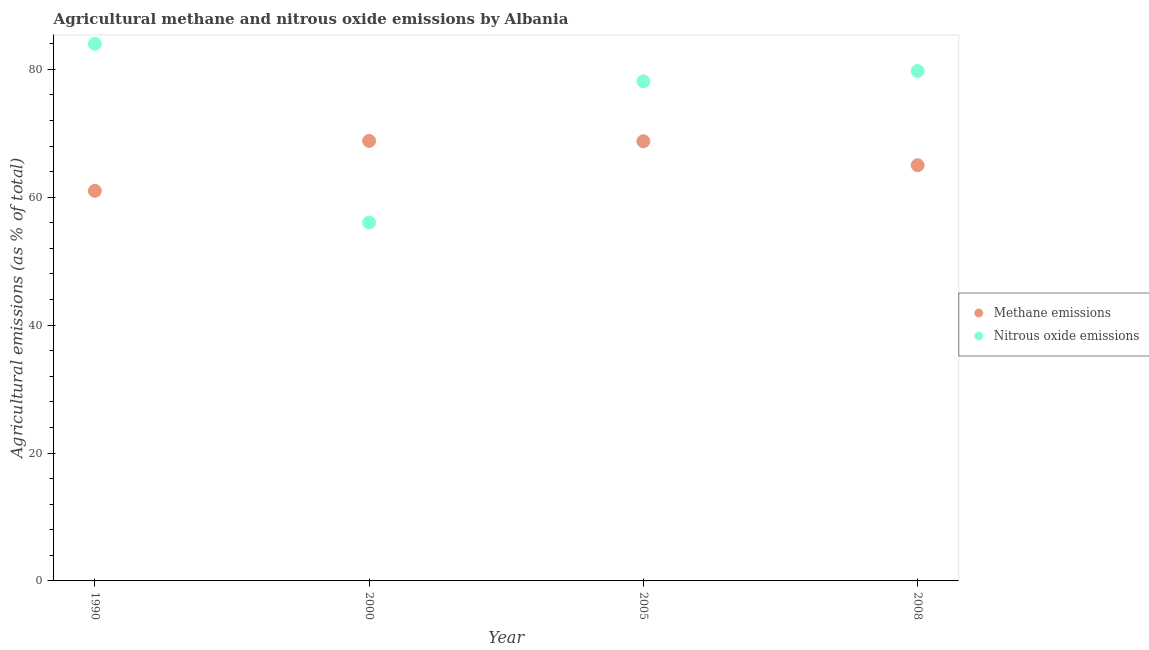Is the number of dotlines equal to the number of legend labels?
Give a very brief answer. Yes. What is the amount of methane emissions in 2008?
Make the answer very short. 65. Across all years, what is the maximum amount of nitrous oxide emissions?
Offer a terse response. 83.98. Across all years, what is the minimum amount of methane emissions?
Keep it short and to the point. 60.99. What is the total amount of methane emissions in the graph?
Keep it short and to the point. 263.54. What is the difference between the amount of nitrous oxide emissions in 1990 and that in 2008?
Your answer should be compact. 4.26. What is the difference between the amount of methane emissions in 1990 and the amount of nitrous oxide emissions in 2008?
Provide a short and direct response. -18.73. What is the average amount of nitrous oxide emissions per year?
Give a very brief answer. 74.46. In the year 2000, what is the difference between the amount of methane emissions and amount of nitrous oxide emissions?
Ensure brevity in your answer.  12.76. In how many years, is the amount of methane emissions greater than 12 %?
Give a very brief answer. 4. What is the ratio of the amount of methane emissions in 2000 to that in 2008?
Provide a short and direct response. 1.06. Is the amount of nitrous oxide emissions in 2000 less than that in 2008?
Ensure brevity in your answer.  Yes. Is the difference between the amount of nitrous oxide emissions in 2000 and 2008 greater than the difference between the amount of methane emissions in 2000 and 2008?
Provide a short and direct response. No. What is the difference between the highest and the second highest amount of methane emissions?
Your response must be concise. 0.06. What is the difference between the highest and the lowest amount of methane emissions?
Provide a short and direct response. 7.81. Is the amount of methane emissions strictly greater than the amount of nitrous oxide emissions over the years?
Your answer should be very brief. No. How many years are there in the graph?
Offer a terse response. 4. What is the difference between two consecutive major ticks on the Y-axis?
Keep it short and to the point. 20. Are the values on the major ticks of Y-axis written in scientific E-notation?
Offer a very short reply. No. Does the graph contain grids?
Provide a succinct answer. No. How many legend labels are there?
Your answer should be very brief. 2. What is the title of the graph?
Offer a terse response. Agricultural methane and nitrous oxide emissions by Albania. What is the label or title of the Y-axis?
Ensure brevity in your answer.  Agricultural emissions (as % of total). What is the Agricultural emissions (as % of total) in Methane emissions in 1990?
Provide a short and direct response. 60.99. What is the Agricultural emissions (as % of total) in Nitrous oxide emissions in 1990?
Give a very brief answer. 83.98. What is the Agricultural emissions (as % of total) of Methane emissions in 2000?
Keep it short and to the point. 68.8. What is the Agricultural emissions (as % of total) in Nitrous oxide emissions in 2000?
Give a very brief answer. 56.04. What is the Agricultural emissions (as % of total) of Methane emissions in 2005?
Give a very brief answer. 68.75. What is the Agricultural emissions (as % of total) in Nitrous oxide emissions in 2005?
Your response must be concise. 78.11. What is the Agricultural emissions (as % of total) in Methane emissions in 2008?
Your answer should be very brief. 65. What is the Agricultural emissions (as % of total) of Nitrous oxide emissions in 2008?
Offer a very short reply. 79.72. Across all years, what is the maximum Agricultural emissions (as % of total) in Methane emissions?
Ensure brevity in your answer.  68.8. Across all years, what is the maximum Agricultural emissions (as % of total) of Nitrous oxide emissions?
Provide a short and direct response. 83.98. Across all years, what is the minimum Agricultural emissions (as % of total) in Methane emissions?
Offer a very short reply. 60.99. Across all years, what is the minimum Agricultural emissions (as % of total) in Nitrous oxide emissions?
Offer a very short reply. 56.04. What is the total Agricultural emissions (as % of total) in Methane emissions in the graph?
Ensure brevity in your answer.  263.54. What is the total Agricultural emissions (as % of total) in Nitrous oxide emissions in the graph?
Offer a very short reply. 297.85. What is the difference between the Agricultural emissions (as % of total) of Methane emissions in 1990 and that in 2000?
Make the answer very short. -7.81. What is the difference between the Agricultural emissions (as % of total) in Nitrous oxide emissions in 1990 and that in 2000?
Your response must be concise. 27.94. What is the difference between the Agricultural emissions (as % of total) of Methane emissions in 1990 and that in 2005?
Provide a succinct answer. -7.75. What is the difference between the Agricultural emissions (as % of total) in Nitrous oxide emissions in 1990 and that in 2005?
Ensure brevity in your answer.  5.87. What is the difference between the Agricultural emissions (as % of total) of Methane emissions in 1990 and that in 2008?
Offer a very short reply. -4.01. What is the difference between the Agricultural emissions (as % of total) in Nitrous oxide emissions in 1990 and that in 2008?
Make the answer very short. 4.26. What is the difference between the Agricultural emissions (as % of total) of Methane emissions in 2000 and that in 2005?
Offer a terse response. 0.06. What is the difference between the Agricultural emissions (as % of total) of Nitrous oxide emissions in 2000 and that in 2005?
Your answer should be compact. -22.07. What is the difference between the Agricultural emissions (as % of total) in Methane emissions in 2000 and that in 2008?
Make the answer very short. 3.8. What is the difference between the Agricultural emissions (as % of total) of Nitrous oxide emissions in 2000 and that in 2008?
Your answer should be very brief. -23.68. What is the difference between the Agricultural emissions (as % of total) in Methane emissions in 2005 and that in 2008?
Provide a succinct answer. 3.75. What is the difference between the Agricultural emissions (as % of total) of Nitrous oxide emissions in 2005 and that in 2008?
Provide a succinct answer. -1.61. What is the difference between the Agricultural emissions (as % of total) in Methane emissions in 1990 and the Agricultural emissions (as % of total) in Nitrous oxide emissions in 2000?
Your response must be concise. 4.95. What is the difference between the Agricultural emissions (as % of total) of Methane emissions in 1990 and the Agricultural emissions (as % of total) of Nitrous oxide emissions in 2005?
Your answer should be compact. -17.12. What is the difference between the Agricultural emissions (as % of total) of Methane emissions in 1990 and the Agricultural emissions (as % of total) of Nitrous oxide emissions in 2008?
Give a very brief answer. -18.73. What is the difference between the Agricultural emissions (as % of total) in Methane emissions in 2000 and the Agricultural emissions (as % of total) in Nitrous oxide emissions in 2005?
Offer a terse response. -9.31. What is the difference between the Agricultural emissions (as % of total) of Methane emissions in 2000 and the Agricultural emissions (as % of total) of Nitrous oxide emissions in 2008?
Provide a succinct answer. -10.92. What is the difference between the Agricultural emissions (as % of total) in Methane emissions in 2005 and the Agricultural emissions (as % of total) in Nitrous oxide emissions in 2008?
Your response must be concise. -10.98. What is the average Agricultural emissions (as % of total) in Methane emissions per year?
Your answer should be very brief. 65.88. What is the average Agricultural emissions (as % of total) in Nitrous oxide emissions per year?
Make the answer very short. 74.46. In the year 1990, what is the difference between the Agricultural emissions (as % of total) in Methane emissions and Agricultural emissions (as % of total) in Nitrous oxide emissions?
Ensure brevity in your answer.  -22.99. In the year 2000, what is the difference between the Agricultural emissions (as % of total) of Methane emissions and Agricultural emissions (as % of total) of Nitrous oxide emissions?
Your answer should be compact. 12.76. In the year 2005, what is the difference between the Agricultural emissions (as % of total) in Methane emissions and Agricultural emissions (as % of total) in Nitrous oxide emissions?
Give a very brief answer. -9.36. In the year 2008, what is the difference between the Agricultural emissions (as % of total) of Methane emissions and Agricultural emissions (as % of total) of Nitrous oxide emissions?
Ensure brevity in your answer.  -14.72. What is the ratio of the Agricultural emissions (as % of total) in Methane emissions in 1990 to that in 2000?
Ensure brevity in your answer.  0.89. What is the ratio of the Agricultural emissions (as % of total) of Nitrous oxide emissions in 1990 to that in 2000?
Make the answer very short. 1.5. What is the ratio of the Agricultural emissions (as % of total) in Methane emissions in 1990 to that in 2005?
Keep it short and to the point. 0.89. What is the ratio of the Agricultural emissions (as % of total) of Nitrous oxide emissions in 1990 to that in 2005?
Offer a terse response. 1.08. What is the ratio of the Agricultural emissions (as % of total) in Methane emissions in 1990 to that in 2008?
Give a very brief answer. 0.94. What is the ratio of the Agricultural emissions (as % of total) of Nitrous oxide emissions in 1990 to that in 2008?
Your response must be concise. 1.05. What is the ratio of the Agricultural emissions (as % of total) of Methane emissions in 2000 to that in 2005?
Ensure brevity in your answer.  1. What is the ratio of the Agricultural emissions (as % of total) in Nitrous oxide emissions in 2000 to that in 2005?
Your response must be concise. 0.72. What is the ratio of the Agricultural emissions (as % of total) in Methane emissions in 2000 to that in 2008?
Your answer should be very brief. 1.06. What is the ratio of the Agricultural emissions (as % of total) in Nitrous oxide emissions in 2000 to that in 2008?
Your answer should be very brief. 0.7. What is the ratio of the Agricultural emissions (as % of total) of Methane emissions in 2005 to that in 2008?
Provide a short and direct response. 1.06. What is the ratio of the Agricultural emissions (as % of total) in Nitrous oxide emissions in 2005 to that in 2008?
Offer a very short reply. 0.98. What is the difference between the highest and the second highest Agricultural emissions (as % of total) in Methane emissions?
Keep it short and to the point. 0.06. What is the difference between the highest and the second highest Agricultural emissions (as % of total) in Nitrous oxide emissions?
Ensure brevity in your answer.  4.26. What is the difference between the highest and the lowest Agricultural emissions (as % of total) in Methane emissions?
Your answer should be compact. 7.81. What is the difference between the highest and the lowest Agricultural emissions (as % of total) in Nitrous oxide emissions?
Offer a very short reply. 27.94. 